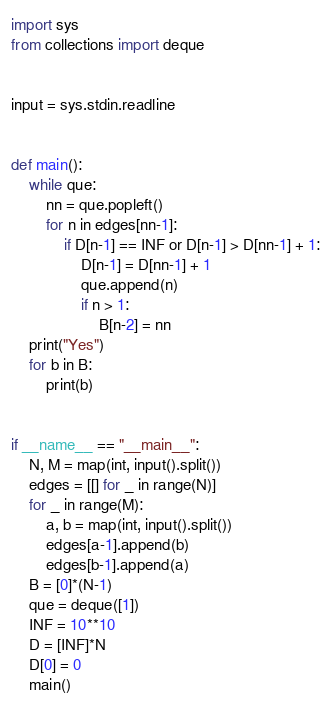<code> <loc_0><loc_0><loc_500><loc_500><_Python_>import sys
from collections import deque


input = sys.stdin.readline


def main():
    while que:
        nn = que.popleft()
        for n in edges[nn-1]:
            if D[n-1] == INF or D[n-1] > D[nn-1] + 1:
                D[n-1] = D[nn-1] + 1
                que.append(n)
                if n > 1:
                    B[n-2] = nn
    print("Yes")
    for b in B:
        print(b)


if __name__ == "__main__":
    N, M = map(int, input().split())
    edges = [[] for _ in range(N)]
    for _ in range(M):
        a, b = map(int, input().split())
        edges[a-1].append(b)
        edges[b-1].append(a)
    B = [0]*(N-1)
    que = deque([1])
    INF = 10**10
    D = [INF]*N
    D[0] = 0
    main()
</code> 